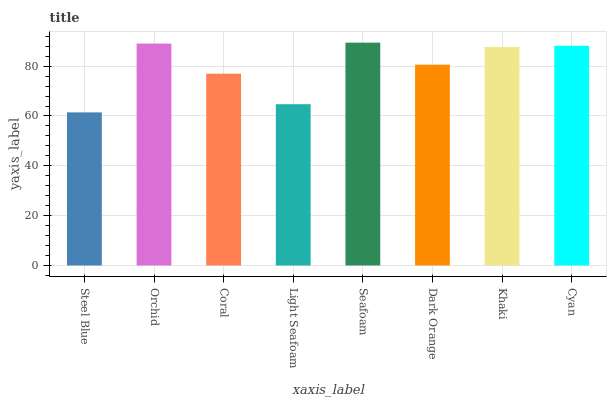Is Steel Blue the minimum?
Answer yes or no. Yes. Is Seafoam the maximum?
Answer yes or no. Yes. Is Orchid the minimum?
Answer yes or no. No. Is Orchid the maximum?
Answer yes or no. No. Is Orchid greater than Steel Blue?
Answer yes or no. Yes. Is Steel Blue less than Orchid?
Answer yes or no. Yes. Is Steel Blue greater than Orchid?
Answer yes or no. No. Is Orchid less than Steel Blue?
Answer yes or no. No. Is Khaki the high median?
Answer yes or no. Yes. Is Dark Orange the low median?
Answer yes or no. Yes. Is Cyan the high median?
Answer yes or no. No. Is Coral the low median?
Answer yes or no. No. 